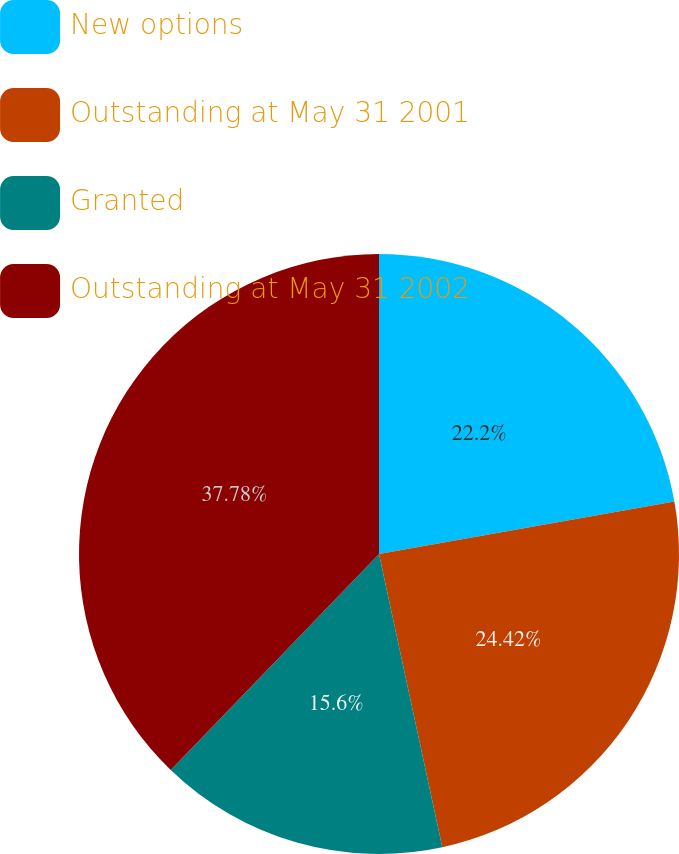Convert chart to OTSL. <chart><loc_0><loc_0><loc_500><loc_500><pie_chart><fcel>New options<fcel>Outstanding at May 31 2001<fcel>Granted<fcel>Outstanding at May 31 2002<nl><fcel>22.2%<fcel>24.42%<fcel>15.6%<fcel>37.79%<nl></chart> 